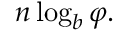<formula> <loc_0><loc_0><loc_500><loc_500>n \log _ { b } \varphi .</formula> 